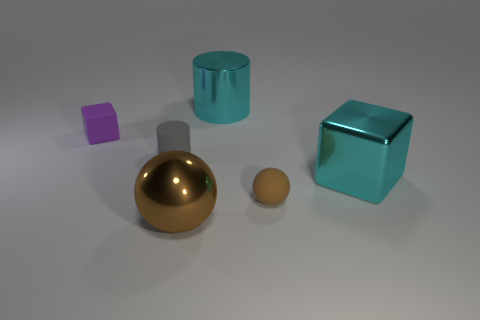Add 1 cyan things. How many objects exist? 7 Subtract all cylinders. How many objects are left? 4 Add 2 shiny cubes. How many shiny cubes are left? 3 Add 2 tiny red metal things. How many tiny red metal things exist? 2 Subtract 0 purple cylinders. How many objects are left? 6 Subtract all purple things. Subtract all large spheres. How many objects are left? 4 